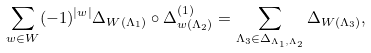<formula> <loc_0><loc_0><loc_500><loc_500>\sum _ { w \in W } ( - 1 ) ^ { | w | } \Delta _ { W ( \Lambda _ { 1 } ) } \circ \Delta _ { w ( \Lambda _ { 2 } ) } ^ { ( 1 ) } = \sum _ { \Lambda _ { 3 } \in \Delta _ { \Lambda _ { 1 } , \Lambda _ { 2 } } } \Delta _ { W ( \Lambda _ { 3 } ) } ,</formula> 